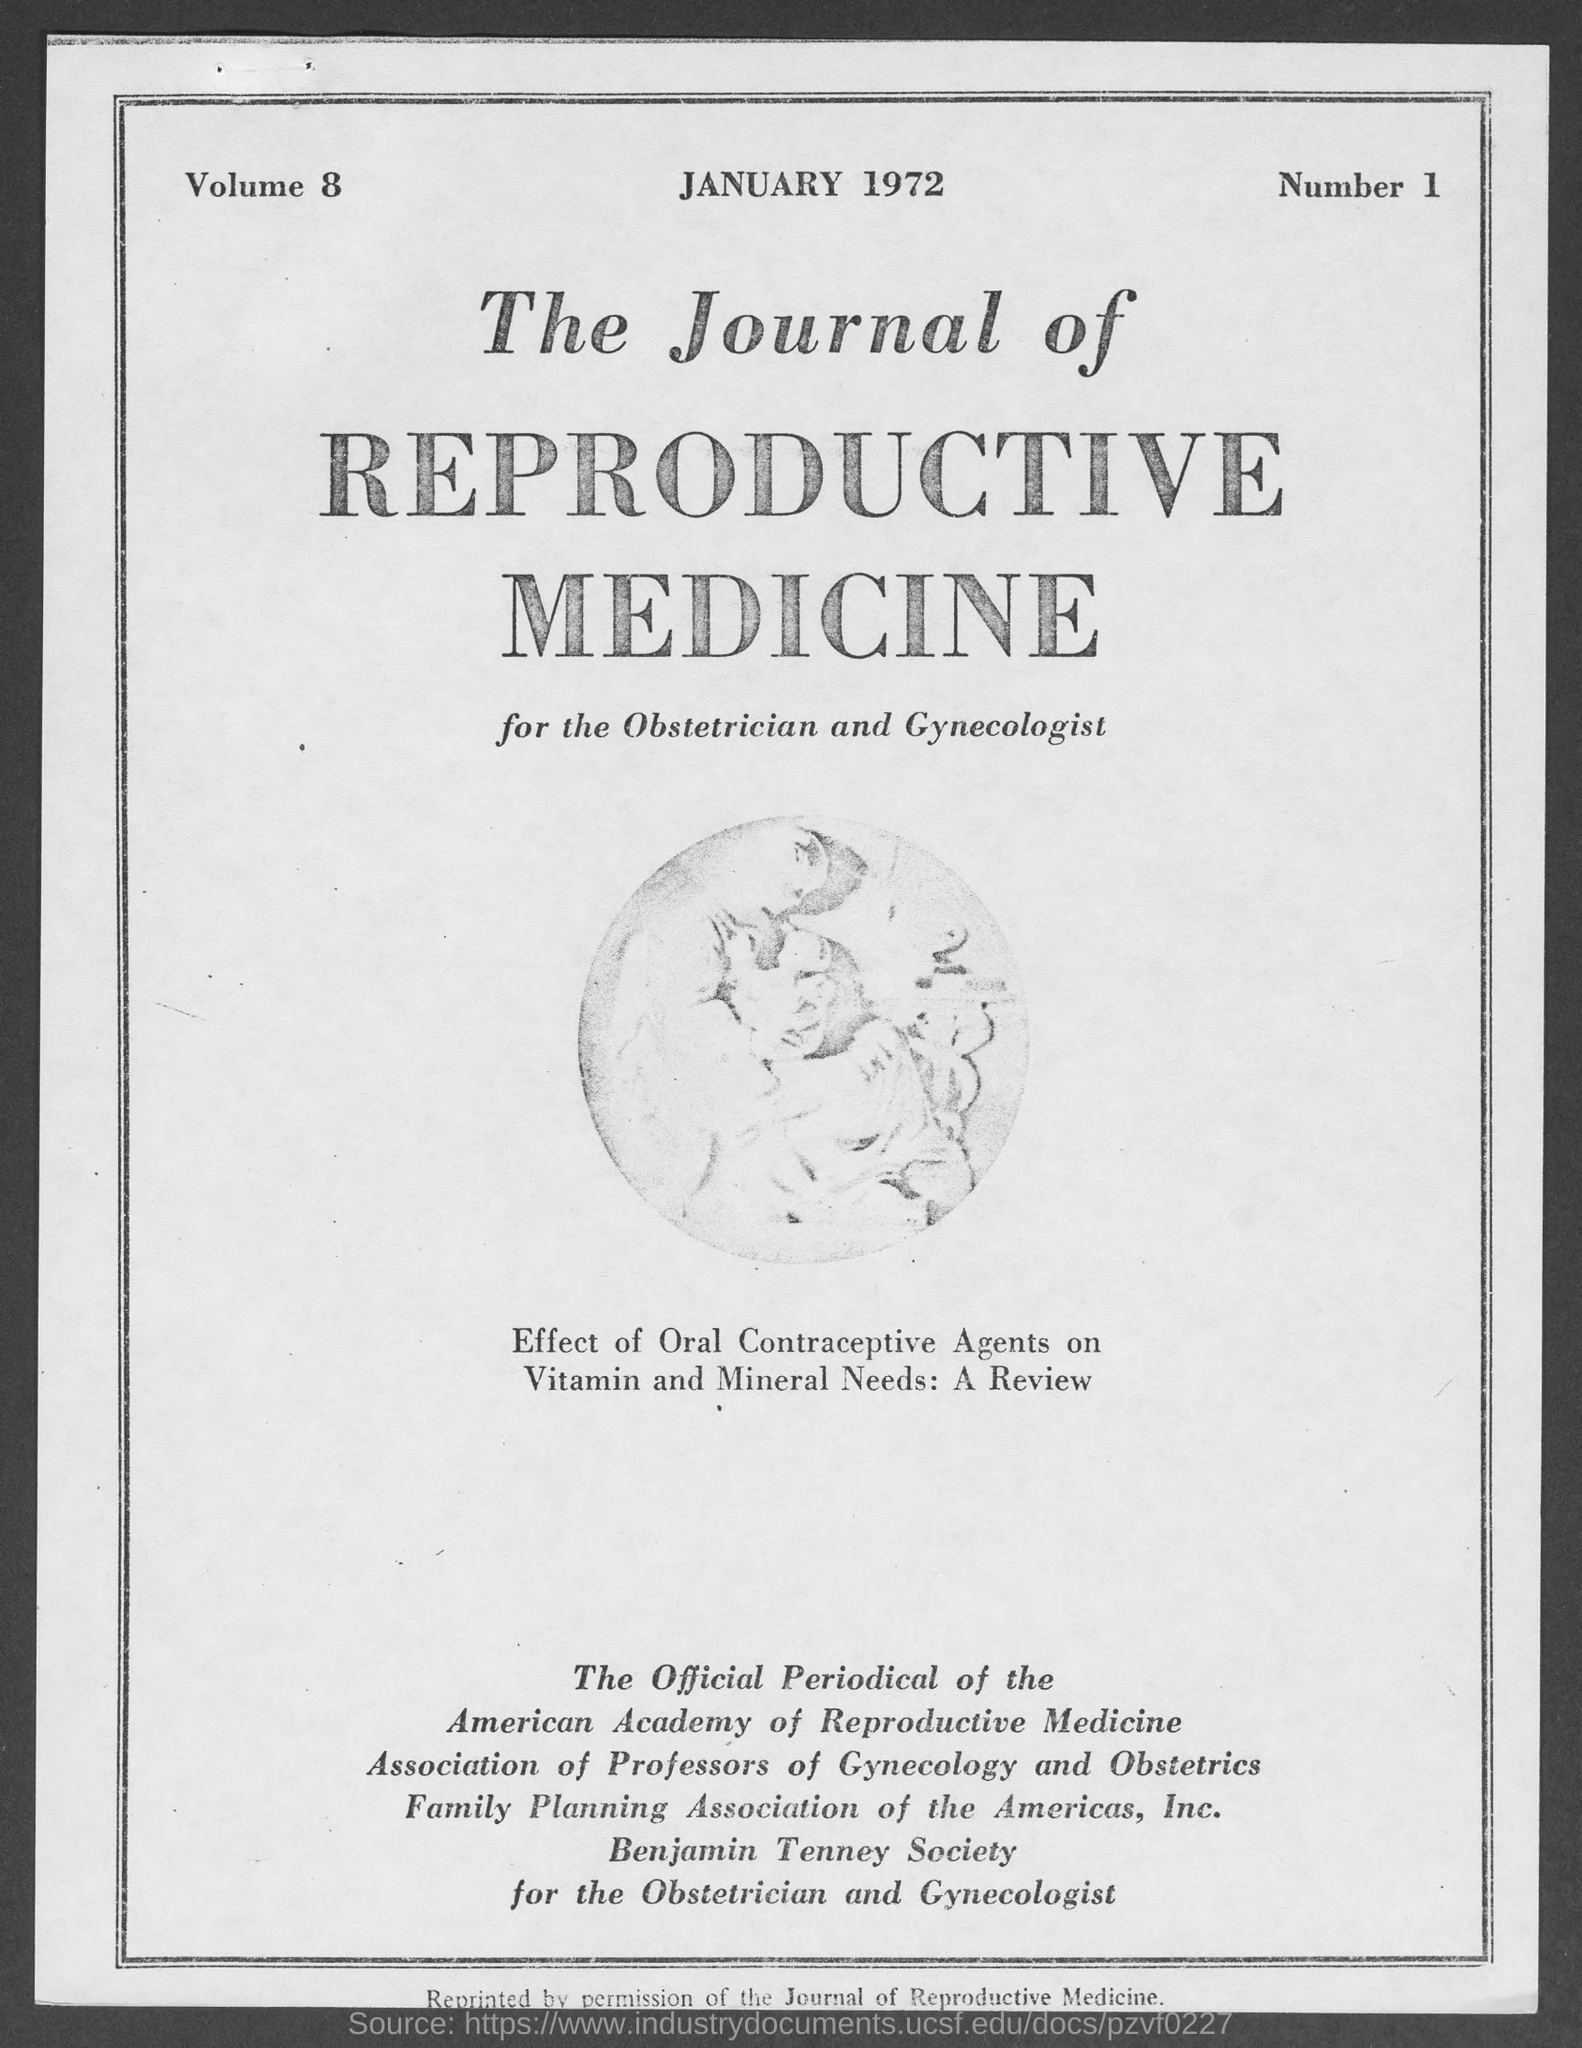Highlight a few significant elements in this photo. The month and year at the top of the page are January 1972. The volume number is 8. 